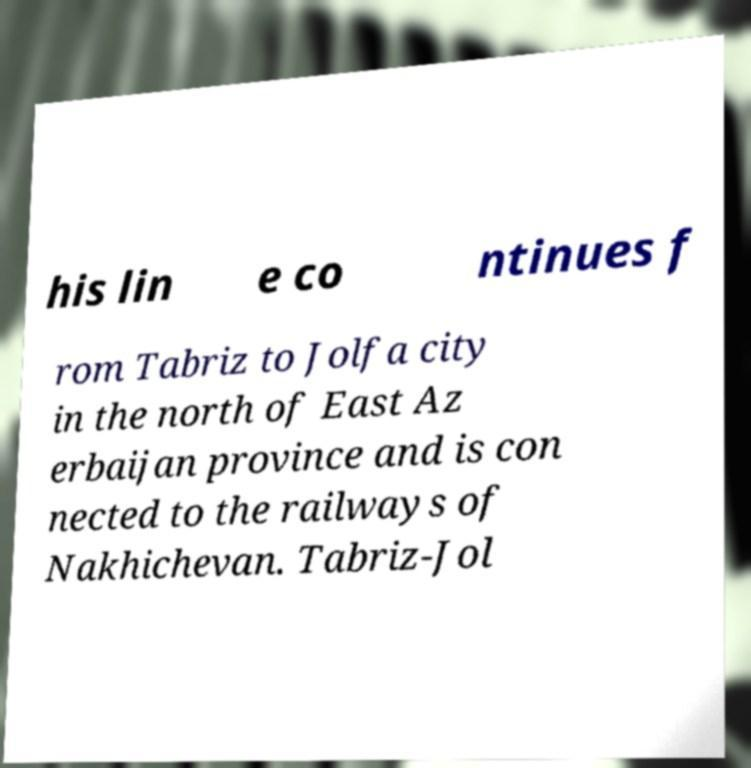I need the written content from this picture converted into text. Can you do that? his lin e co ntinues f rom Tabriz to Jolfa city in the north of East Az erbaijan province and is con nected to the railways of Nakhichevan. Tabriz-Jol 